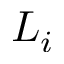Convert formula to latex. <formula><loc_0><loc_0><loc_500><loc_500>L _ { i }</formula> 